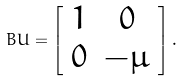<formula> <loc_0><loc_0><loc_500><loc_500>B U = \left [ \begin{array} { c c } 1 & 0 \\ 0 & - \mu \end{array} \right ] .</formula> 